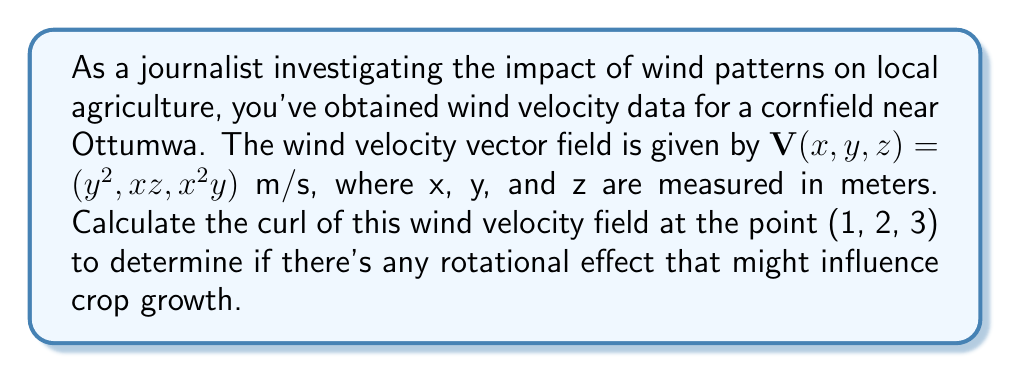Teach me how to tackle this problem. To solve this problem, we need to follow these steps:

1) The curl of a vector field $\mathbf{V}(x,y,z) = (V_x, V_y, V_z)$ is defined as:

   $$\text{curl }\mathbf{V} = \nabla \times \mathbf{V} = \left(\frac{\partial V_z}{\partial y} - \frac{\partial V_y}{\partial z}, \frac{\partial V_x}{\partial z} - \frac{\partial V_z}{\partial x}, \frac{\partial V_y}{\partial x} - \frac{\partial V_x}{\partial y}\right)$$

2) In our case, $V_x = y^2$, $V_y = xz$, and $V_z = x^2y$

3) Let's calculate each component:

   a) $\frac{\partial V_z}{\partial y} - \frac{\partial V_y}{\partial z}$:
      $\frac{\partial V_z}{\partial y} = \frac{\partial (x^2y)}{\partial y} = x^2$
      $\frac{\partial V_y}{\partial z} = \frac{\partial (xz)}{\partial z} = x$
      First component: $x^2 - x$

   b) $\frac{\partial V_x}{\partial z} - \frac{\partial V_z}{\partial x}$:
      $\frac{\partial V_x}{\partial z} = \frac{\partial (y^2)}{\partial z} = 0$
      $\frac{\partial V_z}{\partial x} = \frac{\partial (x^2y)}{\partial x} = 2xy$
      Second component: $0 - 2xy = -2xy$

   c) $\frac{\partial V_y}{\partial x} - \frac{\partial V_x}{\partial y}$:
      $\frac{\partial V_y}{\partial x} = \frac{\partial (xz)}{\partial x} = z$
      $\frac{\partial V_x}{\partial y} = \frac{\partial (y^2)}{\partial y} = 2y$
      Third component: $z - 2y$

4) Therefore, the curl is:
   $$\text{curl }\mathbf{V} = (x^2 - x, -2xy, z - 2y)$$

5) Evaluating at the point (1, 2, 3):
   $$\text{curl }\mathbf{V}(1,2,3) = ((1)^2 - 1, -2(1)(2), 3 - 2(2)) = (0, -4, -1)$$
Answer: $(0, -4, -1)$ m/s 